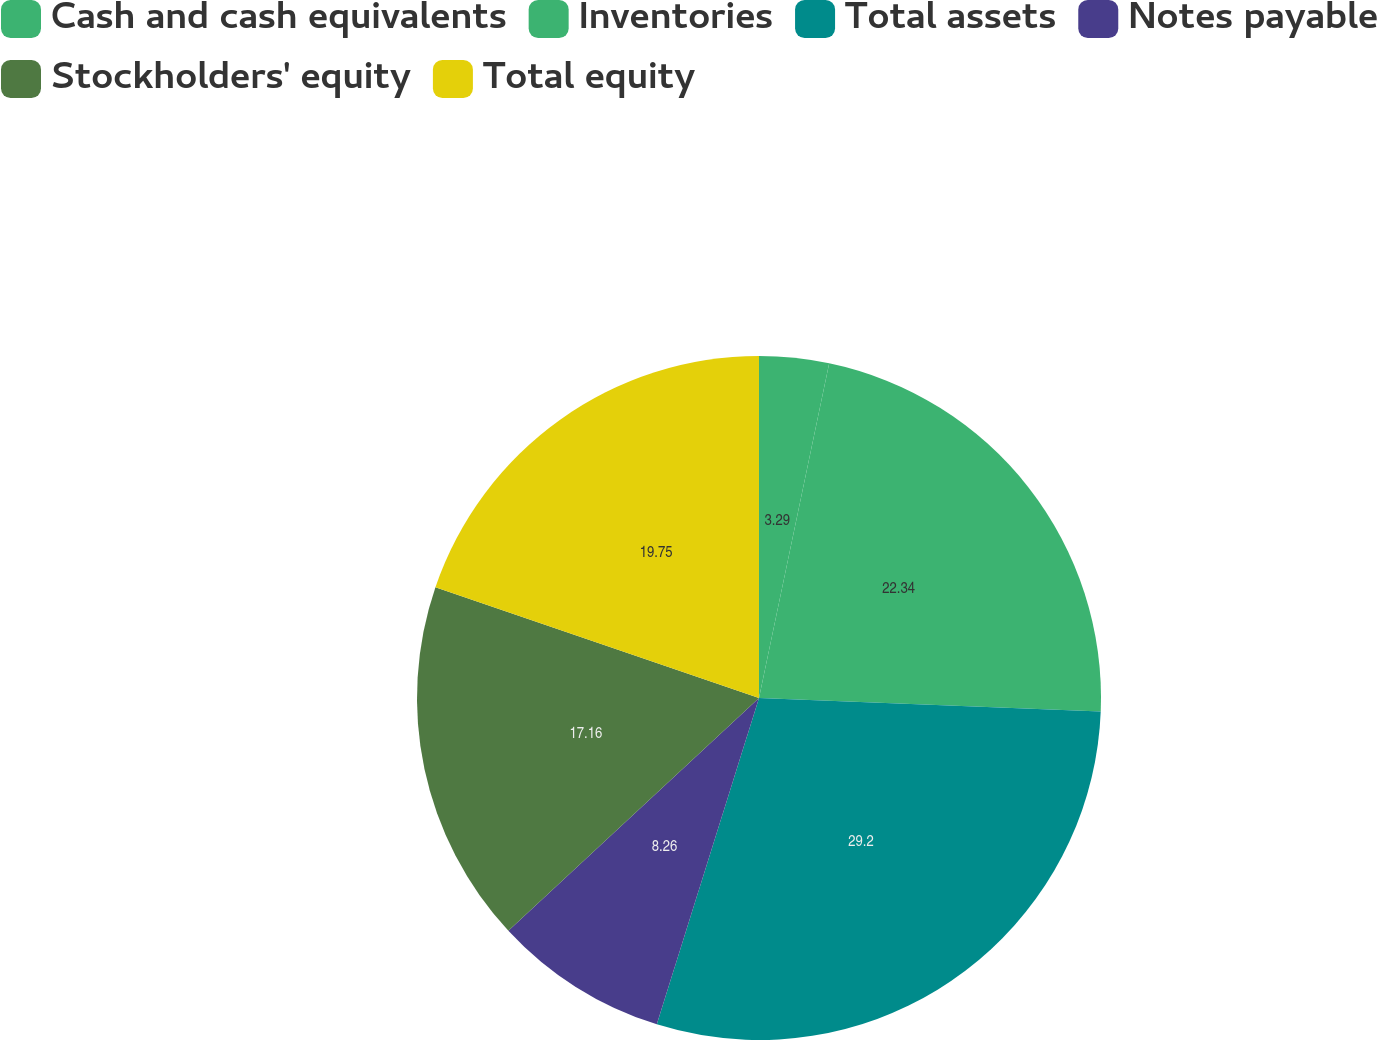Convert chart. <chart><loc_0><loc_0><loc_500><loc_500><pie_chart><fcel>Cash and cash equivalents<fcel>Inventories<fcel>Total assets<fcel>Notes payable<fcel>Stockholders' equity<fcel>Total equity<nl><fcel>3.29%<fcel>22.34%<fcel>29.2%<fcel>8.26%<fcel>17.16%<fcel>19.75%<nl></chart> 